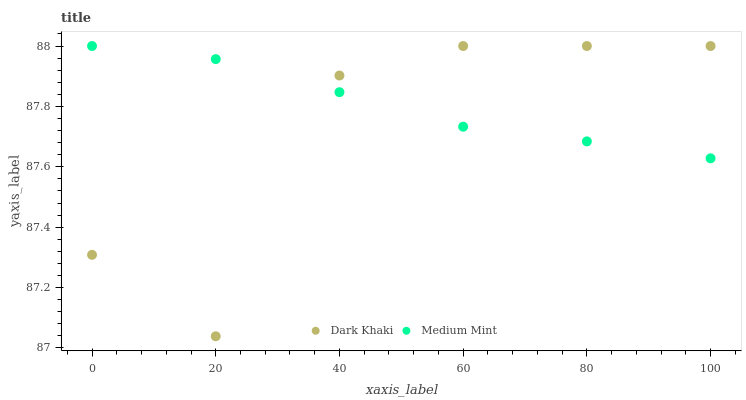Does Dark Khaki have the minimum area under the curve?
Answer yes or no. Yes. Does Medium Mint have the maximum area under the curve?
Answer yes or no. Yes. Does Medium Mint have the minimum area under the curve?
Answer yes or no. No. Is Medium Mint the smoothest?
Answer yes or no. Yes. Is Dark Khaki the roughest?
Answer yes or no. Yes. Is Medium Mint the roughest?
Answer yes or no. No. Does Dark Khaki have the lowest value?
Answer yes or no. Yes. Does Medium Mint have the lowest value?
Answer yes or no. No. Does Medium Mint have the highest value?
Answer yes or no. Yes. Does Dark Khaki intersect Medium Mint?
Answer yes or no. Yes. Is Dark Khaki less than Medium Mint?
Answer yes or no. No. Is Dark Khaki greater than Medium Mint?
Answer yes or no. No. 